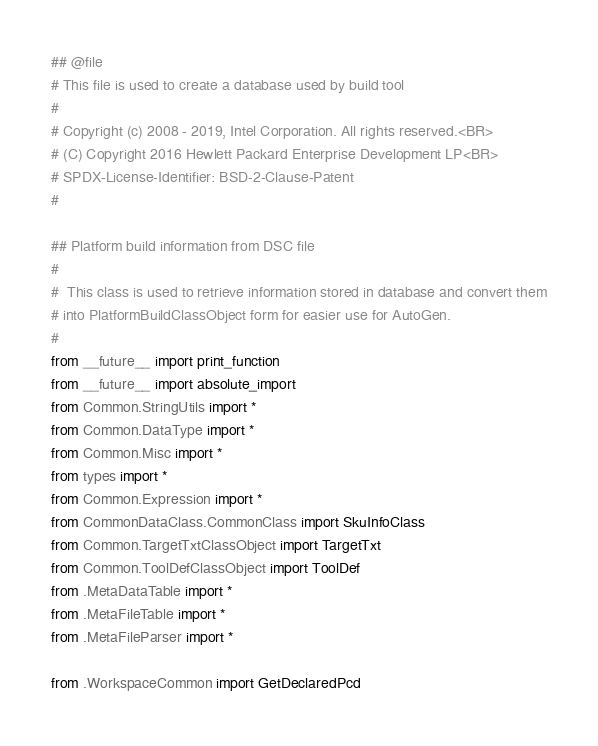<code> <loc_0><loc_0><loc_500><loc_500><_Python_>## @file
# This file is used to create a database used by build tool
#
# Copyright (c) 2008 - 2019, Intel Corporation. All rights reserved.<BR>
# (C) Copyright 2016 Hewlett Packard Enterprise Development LP<BR>
# SPDX-License-Identifier: BSD-2-Clause-Patent
#

## Platform build information from DSC file
#
#  This class is used to retrieve information stored in database and convert them
# into PlatformBuildClassObject form for easier use for AutoGen.
#
from __future__ import print_function
from __future__ import absolute_import
from Common.StringUtils import *
from Common.DataType import *
from Common.Misc import *
from types import *
from Common.Expression import *
from CommonDataClass.CommonClass import SkuInfoClass
from Common.TargetTxtClassObject import TargetTxt
from Common.ToolDefClassObject import ToolDef
from .MetaDataTable import *
from .MetaFileTable import *
from .MetaFileParser import *

from .WorkspaceCommon import GetDeclaredPcd</code> 